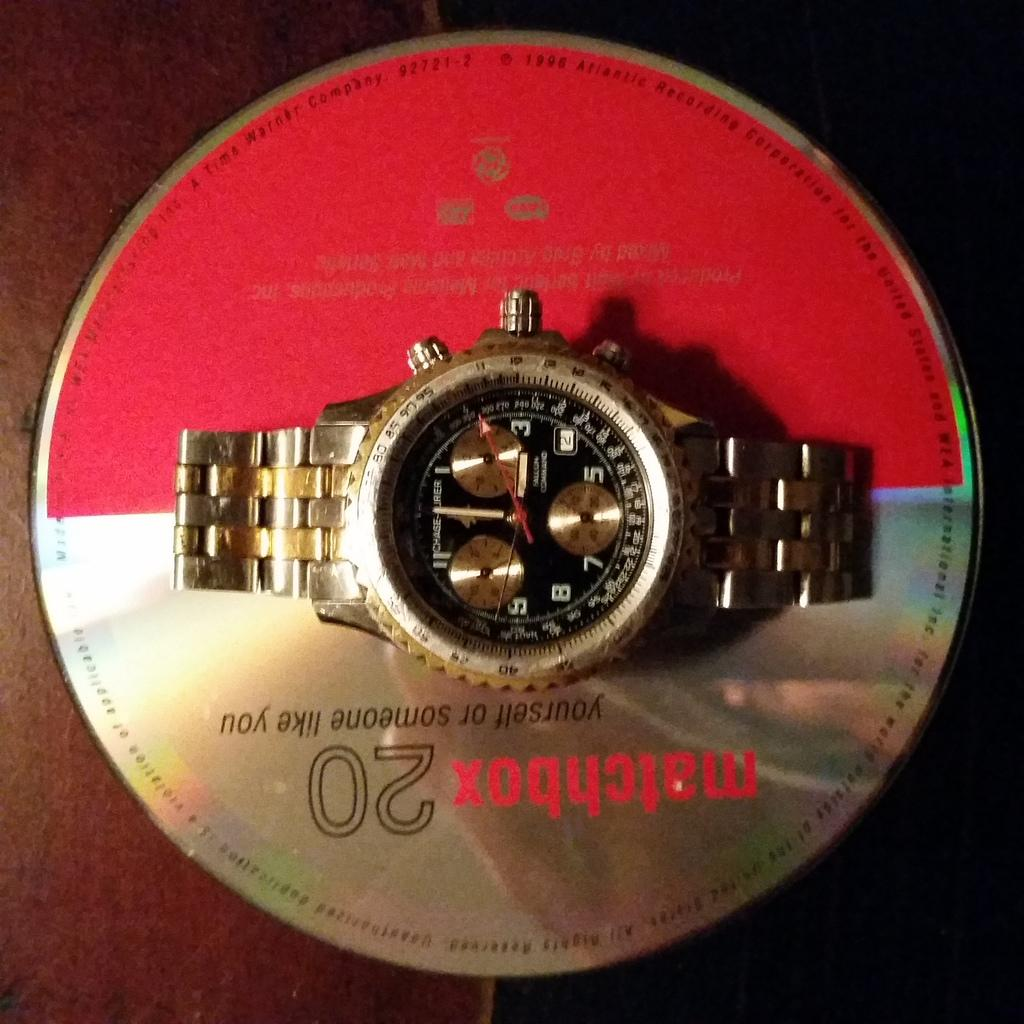<image>
Present a compact description of the photo's key features. A watch is laying atop a Matchbox 20 CD entitled "Yourself or Someone Like You." 